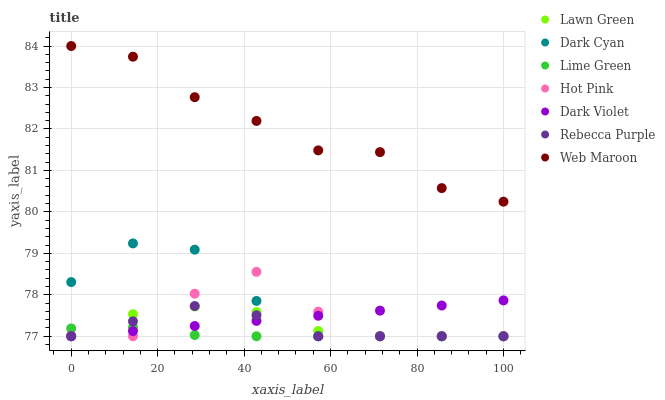Does Lime Green have the minimum area under the curve?
Answer yes or no. Yes. Does Web Maroon have the maximum area under the curve?
Answer yes or no. Yes. Does Hot Pink have the minimum area under the curve?
Answer yes or no. No. Does Hot Pink have the maximum area under the curve?
Answer yes or no. No. Is Dark Violet the smoothest?
Answer yes or no. Yes. Is Hot Pink the roughest?
Answer yes or no. Yes. Is Web Maroon the smoothest?
Answer yes or no. No. Is Web Maroon the roughest?
Answer yes or no. No. Does Lawn Green have the lowest value?
Answer yes or no. Yes. Does Web Maroon have the lowest value?
Answer yes or no. No. Does Web Maroon have the highest value?
Answer yes or no. Yes. Does Hot Pink have the highest value?
Answer yes or no. No. Is Hot Pink less than Web Maroon?
Answer yes or no. Yes. Is Web Maroon greater than Hot Pink?
Answer yes or no. Yes. Does Hot Pink intersect Lawn Green?
Answer yes or no. Yes. Is Hot Pink less than Lawn Green?
Answer yes or no. No. Is Hot Pink greater than Lawn Green?
Answer yes or no. No. Does Hot Pink intersect Web Maroon?
Answer yes or no. No. 